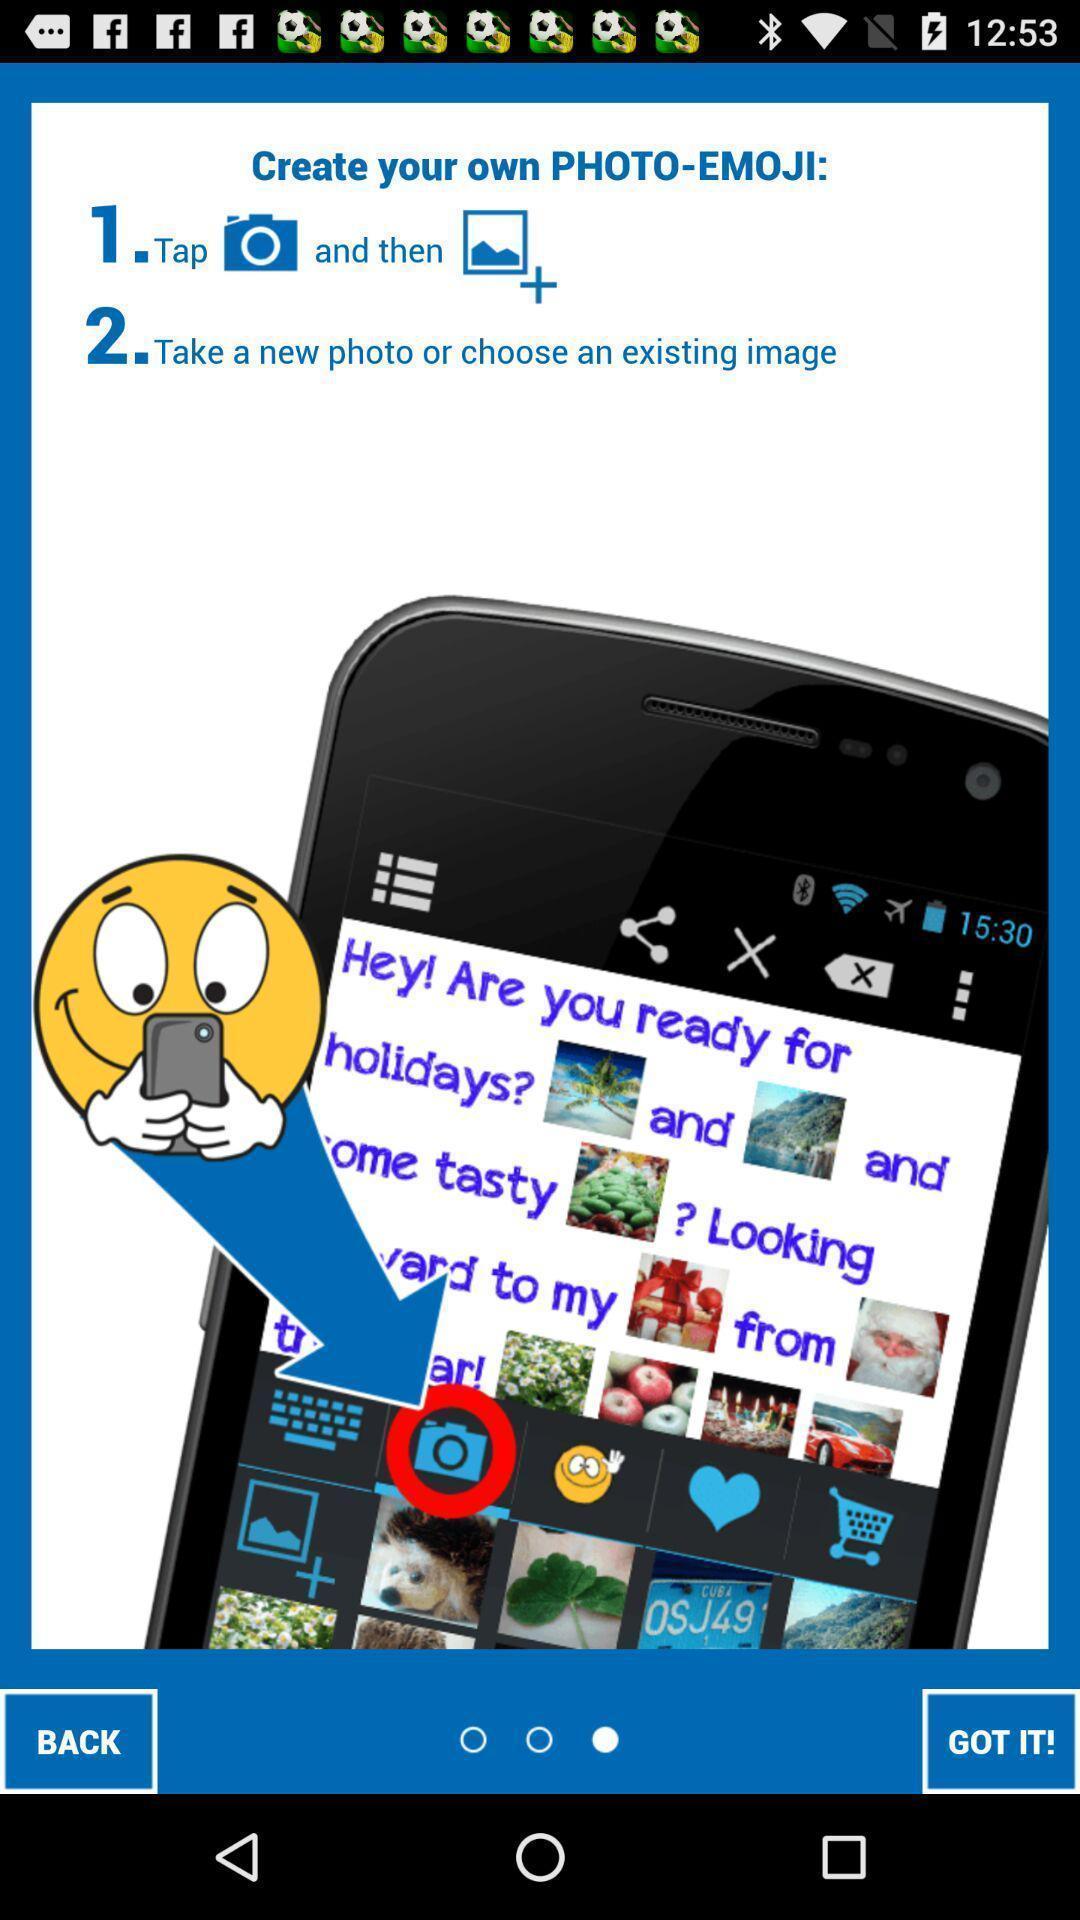What is the overall content of this screenshot? Welcome page of an emoji application. 